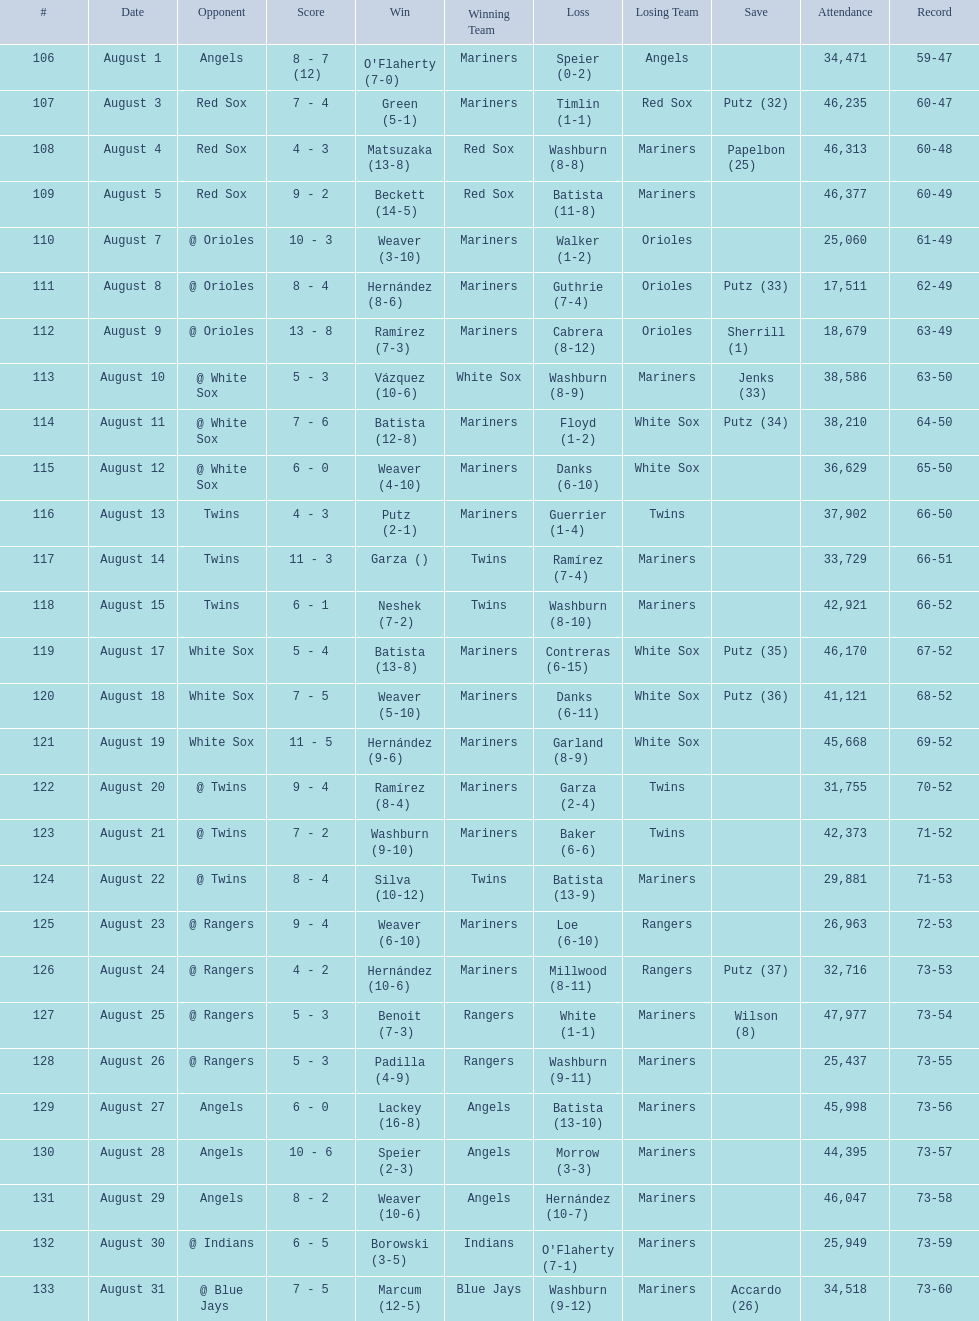What was the total number of games played in august 2007? 28. 